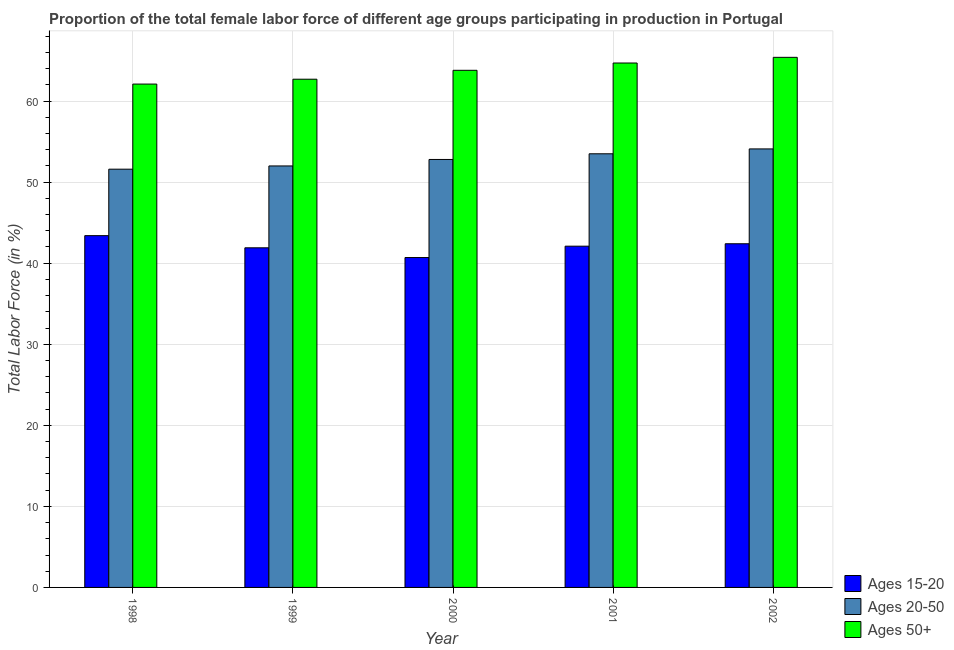How many groups of bars are there?
Make the answer very short. 5. How many bars are there on the 1st tick from the left?
Keep it short and to the point. 3. How many bars are there on the 1st tick from the right?
Your answer should be very brief. 3. What is the label of the 3rd group of bars from the left?
Offer a very short reply. 2000. What is the percentage of female labor force above age 50 in 2001?
Provide a succinct answer. 64.7. Across all years, what is the maximum percentage of female labor force within the age group 20-50?
Your answer should be compact. 54.1. Across all years, what is the minimum percentage of female labor force within the age group 20-50?
Offer a terse response. 51.6. In which year was the percentage of female labor force within the age group 20-50 minimum?
Give a very brief answer. 1998. What is the total percentage of female labor force within the age group 15-20 in the graph?
Your response must be concise. 210.5. What is the difference between the percentage of female labor force within the age group 20-50 in 1999 and that in 2002?
Provide a short and direct response. -2.1. What is the difference between the percentage of female labor force above age 50 in 1998 and the percentage of female labor force within the age group 15-20 in 2002?
Your answer should be compact. -3.3. What is the average percentage of female labor force within the age group 15-20 per year?
Keep it short and to the point. 42.1. In how many years, is the percentage of female labor force within the age group 15-20 greater than 34 %?
Make the answer very short. 5. What is the ratio of the percentage of female labor force within the age group 20-50 in 2000 to that in 2002?
Provide a succinct answer. 0.98. Is the percentage of female labor force above age 50 in 2000 less than that in 2001?
Offer a very short reply. Yes. What is the difference between the highest and the second highest percentage of female labor force above age 50?
Your response must be concise. 0.7. What does the 1st bar from the left in 1998 represents?
Keep it short and to the point. Ages 15-20. What does the 3rd bar from the right in 1998 represents?
Ensure brevity in your answer.  Ages 15-20. Is it the case that in every year, the sum of the percentage of female labor force within the age group 15-20 and percentage of female labor force within the age group 20-50 is greater than the percentage of female labor force above age 50?
Offer a terse response. Yes. Are all the bars in the graph horizontal?
Keep it short and to the point. No. How many years are there in the graph?
Your answer should be very brief. 5. Are the values on the major ticks of Y-axis written in scientific E-notation?
Provide a short and direct response. No. Where does the legend appear in the graph?
Keep it short and to the point. Bottom right. How many legend labels are there?
Your answer should be compact. 3. What is the title of the graph?
Provide a succinct answer. Proportion of the total female labor force of different age groups participating in production in Portugal. What is the label or title of the Y-axis?
Offer a very short reply. Total Labor Force (in %). What is the Total Labor Force (in %) in Ages 15-20 in 1998?
Keep it short and to the point. 43.4. What is the Total Labor Force (in %) in Ages 20-50 in 1998?
Your response must be concise. 51.6. What is the Total Labor Force (in %) of Ages 50+ in 1998?
Your answer should be compact. 62.1. What is the Total Labor Force (in %) in Ages 15-20 in 1999?
Your response must be concise. 41.9. What is the Total Labor Force (in %) in Ages 20-50 in 1999?
Give a very brief answer. 52. What is the Total Labor Force (in %) of Ages 50+ in 1999?
Your answer should be compact. 62.7. What is the Total Labor Force (in %) in Ages 15-20 in 2000?
Offer a very short reply. 40.7. What is the Total Labor Force (in %) in Ages 20-50 in 2000?
Provide a succinct answer. 52.8. What is the Total Labor Force (in %) of Ages 50+ in 2000?
Provide a succinct answer. 63.8. What is the Total Labor Force (in %) in Ages 15-20 in 2001?
Offer a very short reply. 42.1. What is the Total Labor Force (in %) of Ages 20-50 in 2001?
Your response must be concise. 53.5. What is the Total Labor Force (in %) in Ages 50+ in 2001?
Your answer should be compact. 64.7. What is the Total Labor Force (in %) in Ages 15-20 in 2002?
Your answer should be compact. 42.4. What is the Total Labor Force (in %) in Ages 20-50 in 2002?
Offer a terse response. 54.1. What is the Total Labor Force (in %) in Ages 50+ in 2002?
Provide a short and direct response. 65.4. Across all years, what is the maximum Total Labor Force (in %) in Ages 15-20?
Make the answer very short. 43.4. Across all years, what is the maximum Total Labor Force (in %) in Ages 20-50?
Your answer should be compact. 54.1. Across all years, what is the maximum Total Labor Force (in %) in Ages 50+?
Offer a terse response. 65.4. Across all years, what is the minimum Total Labor Force (in %) in Ages 15-20?
Provide a short and direct response. 40.7. Across all years, what is the minimum Total Labor Force (in %) of Ages 20-50?
Offer a very short reply. 51.6. Across all years, what is the minimum Total Labor Force (in %) in Ages 50+?
Offer a very short reply. 62.1. What is the total Total Labor Force (in %) of Ages 15-20 in the graph?
Your answer should be very brief. 210.5. What is the total Total Labor Force (in %) in Ages 20-50 in the graph?
Offer a very short reply. 264. What is the total Total Labor Force (in %) in Ages 50+ in the graph?
Your response must be concise. 318.7. What is the difference between the Total Labor Force (in %) of Ages 15-20 in 1998 and that in 1999?
Give a very brief answer. 1.5. What is the difference between the Total Labor Force (in %) in Ages 50+ in 1998 and that in 1999?
Provide a succinct answer. -0.6. What is the difference between the Total Labor Force (in %) in Ages 20-50 in 1998 and that in 2000?
Ensure brevity in your answer.  -1.2. What is the difference between the Total Labor Force (in %) of Ages 50+ in 1998 and that in 2000?
Provide a succinct answer. -1.7. What is the difference between the Total Labor Force (in %) of Ages 20-50 in 1998 and that in 2001?
Provide a short and direct response. -1.9. What is the difference between the Total Labor Force (in %) of Ages 50+ in 1998 and that in 2001?
Your answer should be very brief. -2.6. What is the difference between the Total Labor Force (in %) in Ages 15-20 in 1998 and that in 2002?
Your answer should be compact. 1. What is the difference between the Total Labor Force (in %) of Ages 20-50 in 1998 and that in 2002?
Make the answer very short. -2.5. What is the difference between the Total Labor Force (in %) in Ages 15-20 in 1999 and that in 2000?
Offer a terse response. 1.2. What is the difference between the Total Labor Force (in %) in Ages 20-50 in 1999 and that in 2000?
Give a very brief answer. -0.8. What is the difference between the Total Labor Force (in %) in Ages 50+ in 1999 and that in 2001?
Your response must be concise. -2. What is the difference between the Total Labor Force (in %) of Ages 20-50 in 1999 and that in 2002?
Your answer should be compact. -2.1. What is the difference between the Total Labor Force (in %) in Ages 50+ in 2000 and that in 2001?
Keep it short and to the point. -0.9. What is the difference between the Total Labor Force (in %) of Ages 20-50 in 2000 and that in 2002?
Your answer should be very brief. -1.3. What is the difference between the Total Labor Force (in %) of Ages 50+ in 2000 and that in 2002?
Provide a short and direct response. -1.6. What is the difference between the Total Labor Force (in %) in Ages 15-20 in 2001 and that in 2002?
Give a very brief answer. -0.3. What is the difference between the Total Labor Force (in %) of Ages 20-50 in 2001 and that in 2002?
Offer a terse response. -0.6. What is the difference between the Total Labor Force (in %) of Ages 15-20 in 1998 and the Total Labor Force (in %) of Ages 20-50 in 1999?
Offer a terse response. -8.6. What is the difference between the Total Labor Force (in %) in Ages 15-20 in 1998 and the Total Labor Force (in %) in Ages 50+ in 1999?
Offer a very short reply. -19.3. What is the difference between the Total Labor Force (in %) in Ages 15-20 in 1998 and the Total Labor Force (in %) in Ages 50+ in 2000?
Keep it short and to the point. -20.4. What is the difference between the Total Labor Force (in %) of Ages 15-20 in 1998 and the Total Labor Force (in %) of Ages 50+ in 2001?
Provide a succinct answer. -21.3. What is the difference between the Total Labor Force (in %) of Ages 15-20 in 1999 and the Total Labor Force (in %) of Ages 20-50 in 2000?
Keep it short and to the point. -10.9. What is the difference between the Total Labor Force (in %) of Ages 15-20 in 1999 and the Total Labor Force (in %) of Ages 50+ in 2000?
Provide a succinct answer. -21.9. What is the difference between the Total Labor Force (in %) of Ages 20-50 in 1999 and the Total Labor Force (in %) of Ages 50+ in 2000?
Your response must be concise. -11.8. What is the difference between the Total Labor Force (in %) in Ages 15-20 in 1999 and the Total Labor Force (in %) in Ages 50+ in 2001?
Ensure brevity in your answer.  -22.8. What is the difference between the Total Labor Force (in %) of Ages 15-20 in 1999 and the Total Labor Force (in %) of Ages 20-50 in 2002?
Your answer should be very brief. -12.2. What is the difference between the Total Labor Force (in %) in Ages 15-20 in 1999 and the Total Labor Force (in %) in Ages 50+ in 2002?
Offer a very short reply. -23.5. What is the difference between the Total Labor Force (in %) of Ages 20-50 in 2000 and the Total Labor Force (in %) of Ages 50+ in 2001?
Your answer should be very brief. -11.9. What is the difference between the Total Labor Force (in %) of Ages 15-20 in 2000 and the Total Labor Force (in %) of Ages 20-50 in 2002?
Provide a short and direct response. -13.4. What is the difference between the Total Labor Force (in %) in Ages 15-20 in 2000 and the Total Labor Force (in %) in Ages 50+ in 2002?
Ensure brevity in your answer.  -24.7. What is the difference between the Total Labor Force (in %) of Ages 20-50 in 2000 and the Total Labor Force (in %) of Ages 50+ in 2002?
Your response must be concise. -12.6. What is the difference between the Total Labor Force (in %) of Ages 15-20 in 2001 and the Total Labor Force (in %) of Ages 50+ in 2002?
Provide a succinct answer. -23.3. What is the average Total Labor Force (in %) in Ages 15-20 per year?
Make the answer very short. 42.1. What is the average Total Labor Force (in %) of Ages 20-50 per year?
Give a very brief answer. 52.8. What is the average Total Labor Force (in %) in Ages 50+ per year?
Offer a very short reply. 63.74. In the year 1998, what is the difference between the Total Labor Force (in %) of Ages 15-20 and Total Labor Force (in %) of Ages 50+?
Give a very brief answer. -18.7. In the year 1998, what is the difference between the Total Labor Force (in %) in Ages 20-50 and Total Labor Force (in %) in Ages 50+?
Give a very brief answer. -10.5. In the year 1999, what is the difference between the Total Labor Force (in %) in Ages 15-20 and Total Labor Force (in %) in Ages 50+?
Give a very brief answer. -20.8. In the year 2000, what is the difference between the Total Labor Force (in %) of Ages 15-20 and Total Labor Force (in %) of Ages 20-50?
Provide a short and direct response. -12.1. In the year 2000, what is the difference between the Total Labor Force (in %) in Ages 15-20 and Total Labor Force (in %) in Ages 50+?
Offer a terse response. -23.1. In the year 2000, what is the difference between the Total Labor Force (in %) of Ages 20-50 and Total Labor Force (in %) of Ages 50+?
Your answer should be compact. -11. In the year 2001, what is the difference between the Total Labor Force (in %) of Ages 15-20 and Total Labor Force (in %) of Ages 20-50?
Ensure brevity in your answer.  -11.4. In the year 2001, what is the difference between the Total Labor Force (in %) in Ages 15-20 and Total Labor Force (in %) in Ages 50+?
Your response must be concise. -22.6. In the year 2001, what is the difference between the Total Labor Force (in %) of Ages 20-50 and Total Labor Force (in %) of Ages 50+?
Make the answer very short. -11.2. In the year 2002, what is the difference between the Total Labor Force (in %) of Ages 20-50 and Total Labor Force (in %) of Ages 50+?
Your answer should be compact. -11.3. What is the ratio of the Total Labor Force (in %) of Ages 15-20 in 1998 to that in 1999?
Provide a short and direct response. 1.04. What is the ratio of the Total Labor Force (in %) in Ages 20-50 in 1998 to that in 1999?
Offer a very short reply. 0.99. What is the ratio of the Total Labor Force (in %) in Ages 50+ in 1998 to that in 1999?
Provide a succinct answer. 0.99. What is the ratio of the Total Labor Force (in %) of Ages 15-20 in 1998 to that in 2000?
Your answer should be compact. 1.07. What is the ratio of the Total Labor Force (in %) of Ages 20-50 in 1998 to that in 2000?
Keep it short and to the point. 0.98. What is the ratio of the Total Labor Force (in %) in Ages 50+ in 1998 to that in 2000?
Provide a succinct answer. 0.97. What is the ratio of the Total Labor Force (in %) of Ages 15-20 in 1998 to that in 2001?
Give a very brief answer. 1.03. What is the ratio of the Total Labor Force (in %) of Ages 20-50 in 1998 to that in 2001?
Keep it short and to the point. 0.96. What is the ratio of the Total Labor Force (in %) in Ages 50+ in 1998 to that in 2001?
Offer a very short reply. 0.96. What is the ratio of the Total Labor Force (in %) in Ages 15-20 in 1998 to that in 2002?
Offer a terse response. 1.02. What is the ratio of the Total Labor Force (in %) in Ages 20-50 in 1998 to that in 2002?
Provide a short and direct response. 0.95. What is the ratio of the Total Labor Force (in %) in Ages 50+ in 1998 to that in 2002?
Offer a very short reply. 0.95. What is the ratio of the Total Labor Force (in %) in Ages 15-20 in 1999 to that in 2000?
Your response must be concise. 1.03. What is the ratio of the Total Labor Force (in %) in Ages 20-50 in 1999 to that in 2000?
Provide a succinct answer. 0.98. What is the ratio of the Total Labor Force (in %) of Ages 50+ in 1999 to that in 2000?
Offer a very short reply. 0.98. What is the ratio of the Total Labor Force (in %) of Ages 20-50 in 1999 to that in 2001?
Provide a short and direct response. 0.97. What is the ratio of the Total Labor Force (in %) in Ages 50+ in 1999 to that in 2001?
Give a very brief answer. 0.97. What is the ratio of the Total Labor Force (in %) of Ages 15-20 in 1999 to that in 2002?
Your response must be concise. 0.99. What is the ratio of the Total Labor Force (in %) in Ages 20-50 in 1999 to that in 2002?
Keep it short and to the point. 0.96. What is the ratio of the Total Labor Force (in %) of Ages 50+ in 1999 to that in 2002?
Make the answer very short. 0.96. What is the ratio of the Total Labor Force (in %) of Ages 15-20 in 2000 to that in 2001?
Provide a succinct answer. 0.97. What is the ratio of the Total Labor Force (in %) of Ages 20-50 in 2000 to that in 2001?
Your response must be concise. 0.99. What is the ratio of the Total Labor Force (in %) in Ages 50+ in 2000 to that in 2001?
Provide a succinct answer. 0.99. What is the ratio of the Total Labor Force (in %) in Ages 15-20 in 2000 to that in 2002?
Provide a short and direct response. 0.96. What is the ratio of the Total Labor Force (in %) in Ages 20-50 in 2000 to that in 2002?
Keep it short and to the point. 0.98. What is the ratio of the Total Labor Force (in %) in Ages 50+ in 2000 to that in 2002?
Your answer should be very brief. 0.98. What is the ratio of the Total Labor Force (in %) in Ages 20-50 in 2001 to that in 2002?
Provide a succinct answer. 0.99. What is the ratio of the Total Labor Force (in %) of Ages 50+ in 2001 to that in 2002?
Ensure brevity in your answer.  0.99. What is the difference between the highest and the second highest Total Labor Force (in %) of Ages 15-20?
Offer a terse response. 1. What is the difference between the highest and the second highest Total Labor Force (in %) of Ages 20-50?
Keep it short and to the point. 0.6. What is the difference between the highest and the second highest Total Labor Force (in %) in Ages 50+?
Ensure brevity in your answer.  0.7. What is the difference between the highest and the lowest Total Labor Force (in %) in Ages 15-20?
Your answer should be very brief. 2.7. 